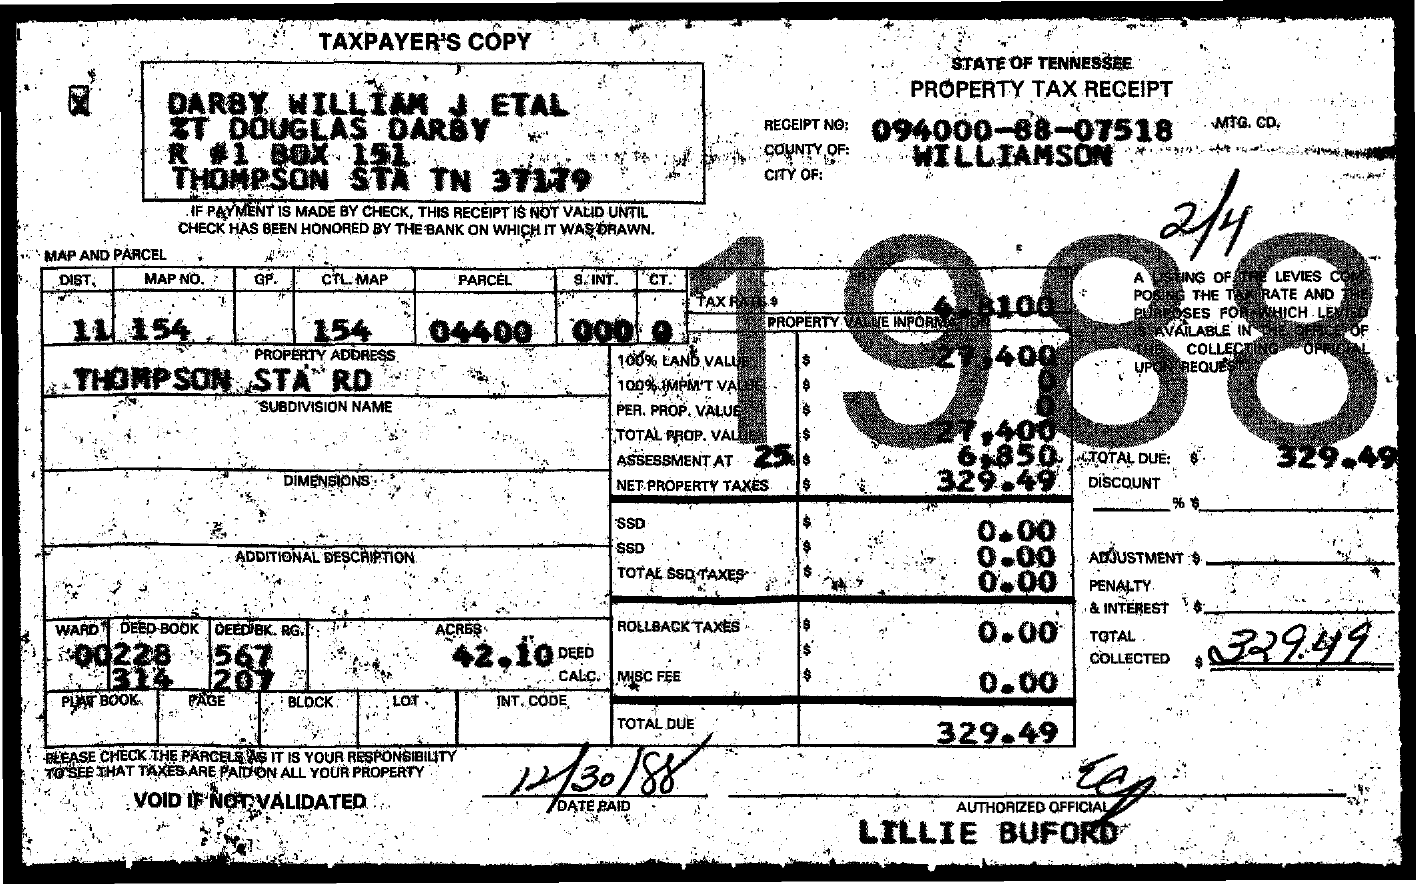What is the Receipt No?
Provide a short and direct response. 094000-88-07518. What is the total tax collected?
Keep it short and to the point. 329.49. 